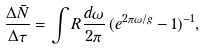<formula> <loc_0><loc_0><loc_500><loc_500>\frac { \Delta \bar { N } } { \Delta \tau } = \int R \frac { d \omega } { 2 \pi } \, ( e ^ { 2 \pi \omega / g } - 1 ) ^ { - 1 } ,</formula> 